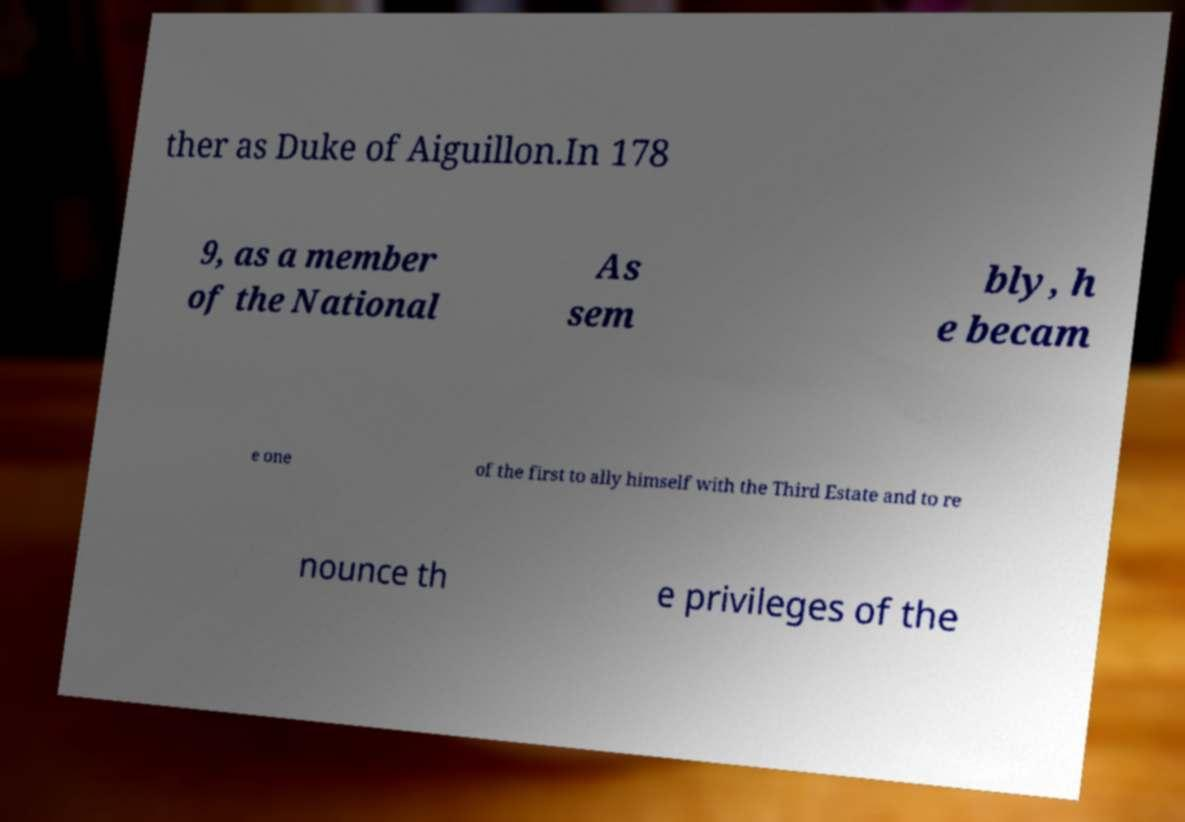Could you assist in decoding the text presented in this image and type it out clearly? ther as Duke of Aiguillon.In 178 9, as a member of the National As sem bly, h e becam e one of the first to ally himself with the Third Estate and to re nounce th e privileges of the 